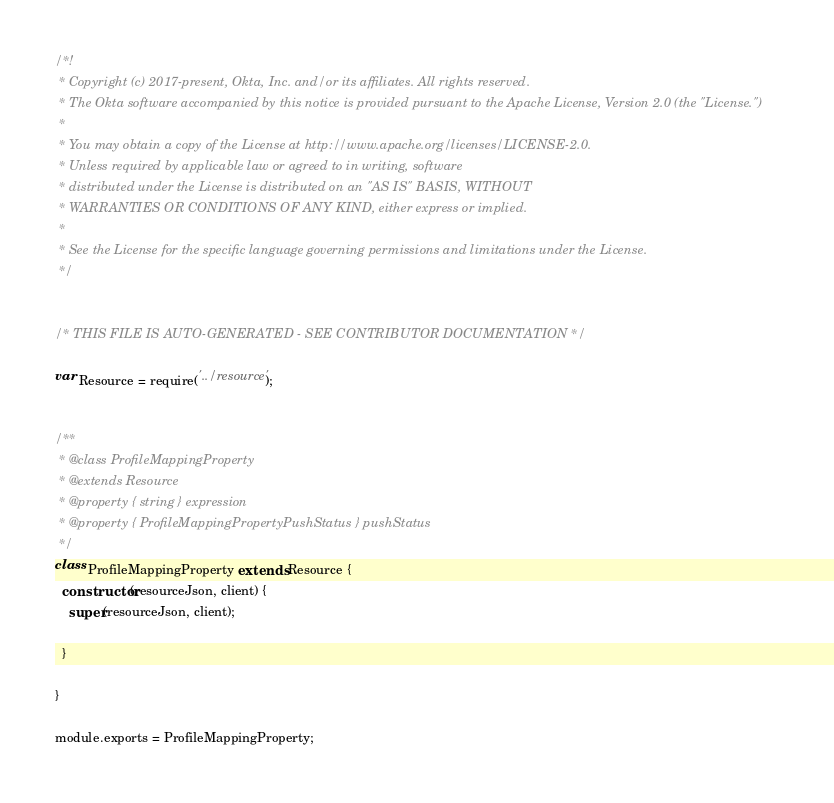Convert code to text. <code><loc_0><loc_0><loc_500><loc_500><_JavaScript_>/*!
 * Copyright (c) 2017-present, Okta, Inc. and/or its affiliates. All rights reserved.
 * The Okta software accompanied by this notice is provided pursuant to the Apache License, Version 2.0 (the "License.")
 *
 * You may obtain a copy of the License at http://www.apache.org/licenses/LICENSE-2.0.
 * Unless required by applicable law or agreed to in writing, software
 * distributed under the License is distributed on an "AS IS" BASIS, WITHOUT
 * WARRANTIES OR CONDITIONS OF ANY KIND, either express or implied.
 *
 * See the License for the specific language governing permissions and limitations under the License.
 */


/* THIS FILE IS AUTO-GENERATED - SEE CONTRIBUTOR DOCUMENTATION */

var Resource = require('../resource');


/**
 * @class ProfileMappingProperty
 * @extends Resource
 * @property { string } expression
 * @property { ProfileMappingPropertyPushStatus } pushStatus
 */
class ProfileMappingProperty extends Resource {
  constructor(resourceJson, client) {
    super(resourceJson, client);

  }

}

module.exports = ProfileMappingProperty;
</code> 